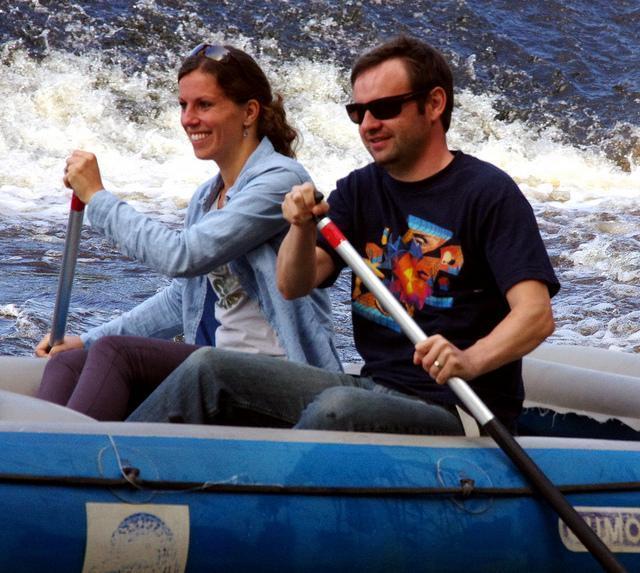What should they have worn before starting the activity?
Pick the correct solution from the four options below to address the question.
Options: Life jacket, headband, wristband, helmet. Life jacket. 